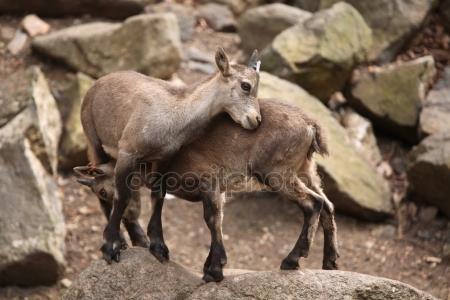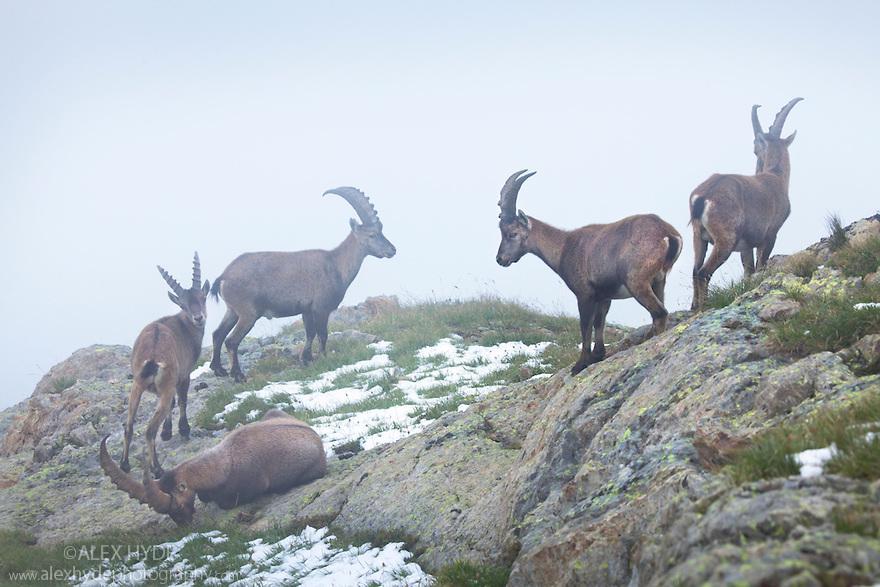The first image is the image on the left, the second image is the image on the right. For the images displayed, is the sentence "Two cloven animals are nudging each other with their heads." factually correct? Answer yes or no. Yes. The first image is the image on the left, the second image is the image on the right. Examine the images to the left and right. Is the description "The image to the left contains more than one goat." accurate? Answer yes or no. Yes. 